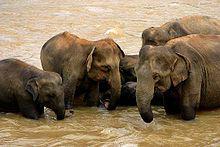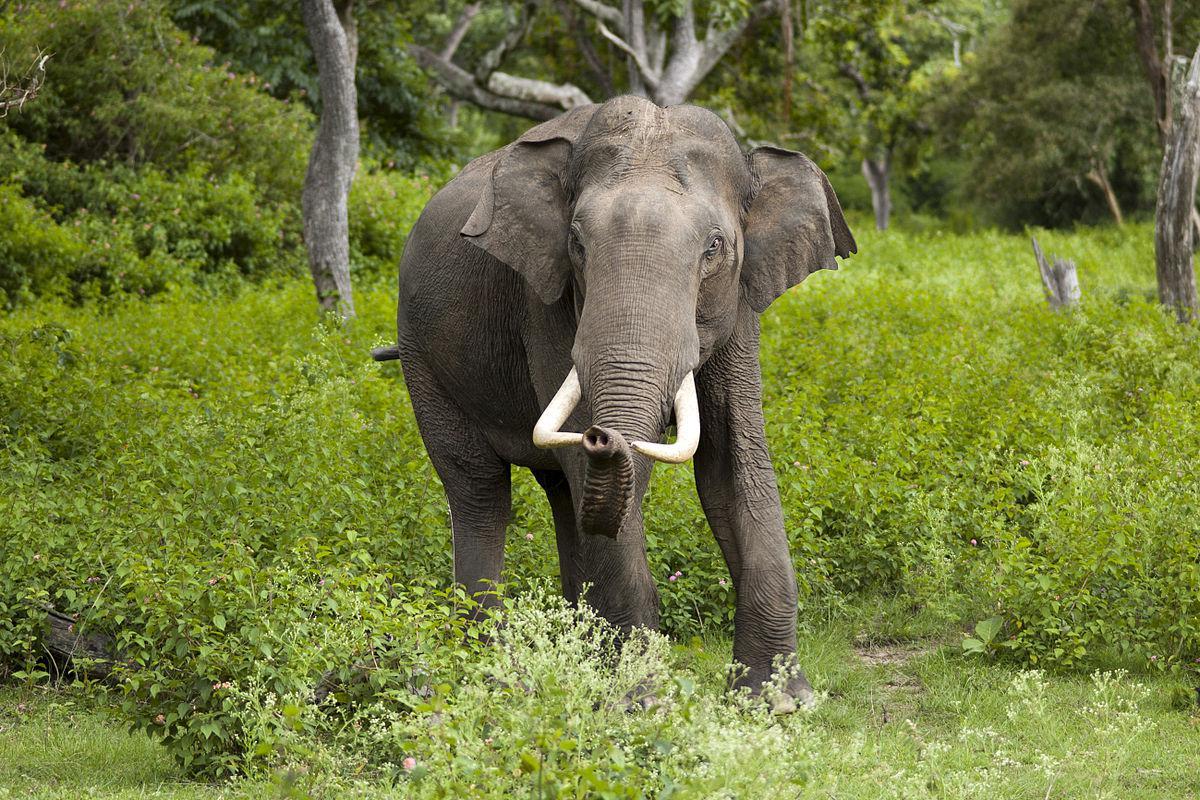The first image is the image on the left, the second image is the image on the right. Given the left and right images, does the statement "All elephants have ivory tusks." hold true? Answer yes or no. No. 